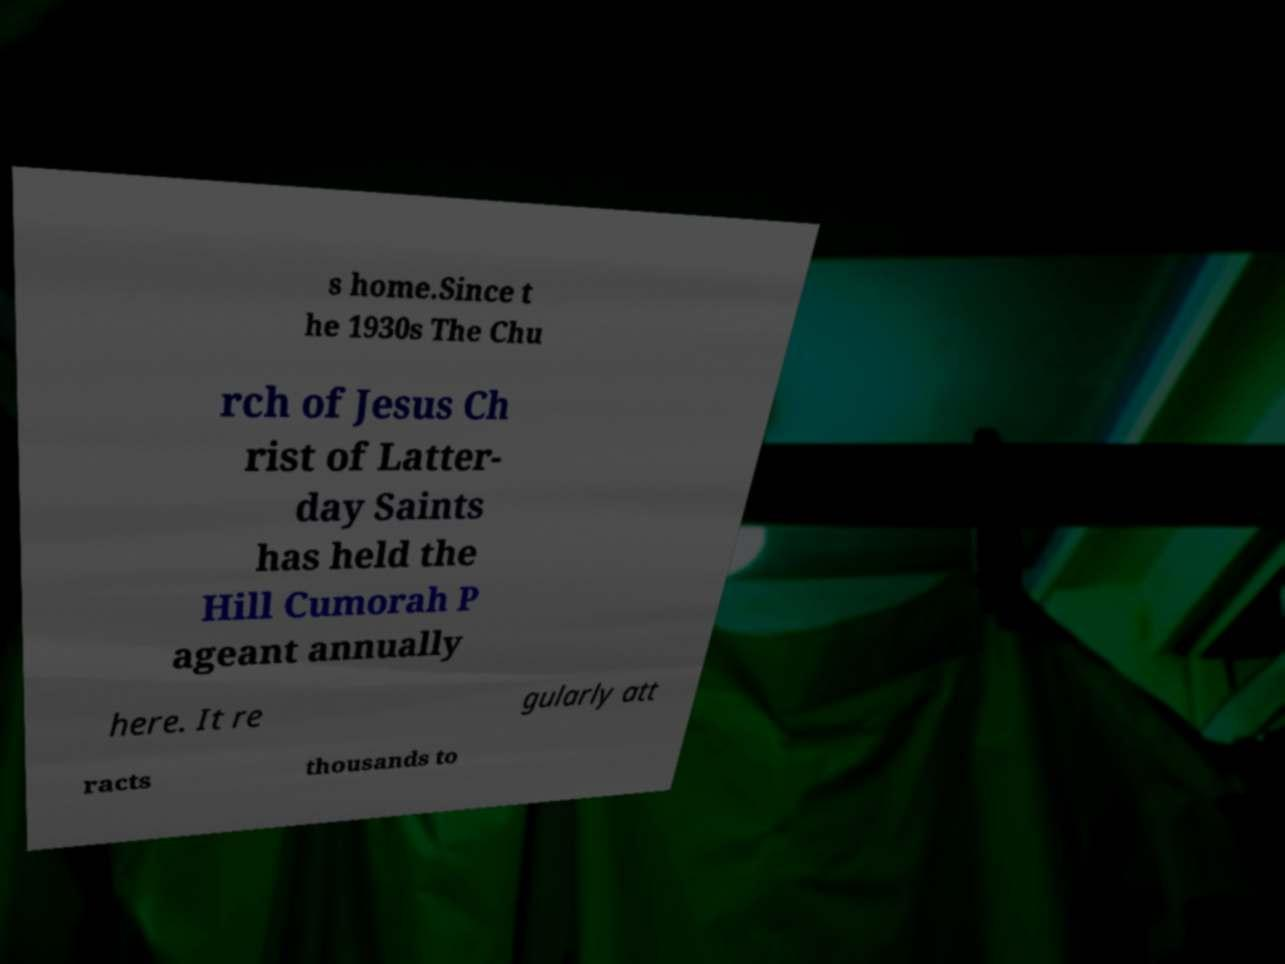Could you assist in decoding the text presented in this image and type it out clearly? s home.Since t he 1930s The Chu rch of Jesus Ch rist of Latter- day Saints has held the Hill Cumorah P ageant annually here. It re gularly att racts thousands to 